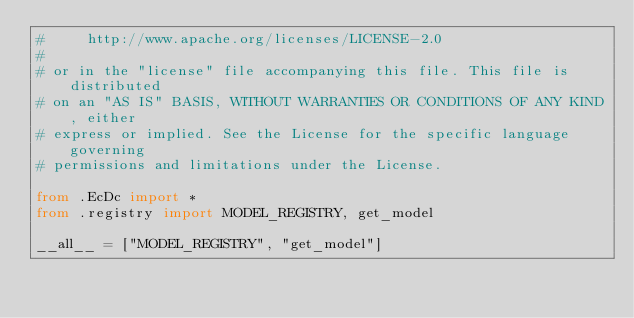Convert code to text. <code><loc_0><loc_0><loc_500><loc_500><_Python_>#     http://www.apache.org/licenses/LICENSE-2.0
#
# or in the "license" file accompanying this file. This file is distributed
# on an "AS IS" BASIS, WITHOUT WARRANTIES OR CONDITIONS OF ANY KIND, either
# express or implied. See the License for the specific language governing
# permissions and limitations under the License.

from .EcDc import *
from .registry import MODEL_REGISTRY, get_model

__all__ = ["MODEL_REGISTRY", "get_model"]
</code> 